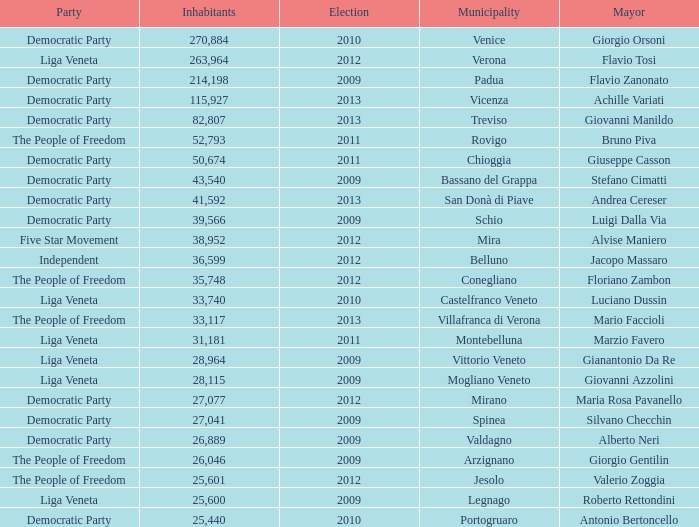What party was achille variati afilliated with? Democratic Party. 